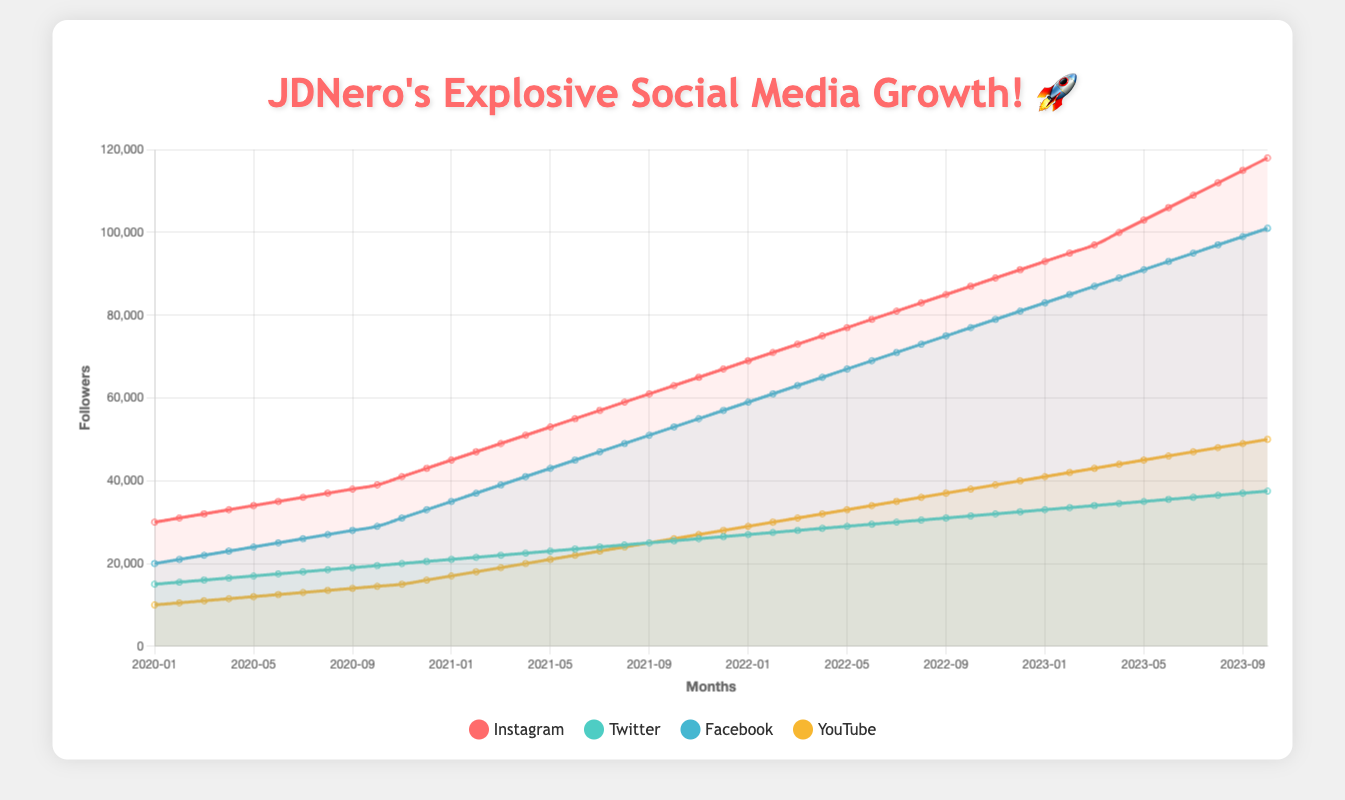What is the total number of followers JDNero had on Instagram by the end of 2022? At the end of 2022, the number of followers on Instagram is represented by the data point for December 2022. Referring to that data point in the "Instagram" series shows 91,000 followers.
Answer: 91,000 Which platform had the highest growth in followers from January 2020 to October 2023? To determine which platform had the highest growth, we need to subtract the number of followers in January 2020 from the number of followers in October 2023 for each platform. Instagram (118,000 - 30,000 = 88,000), Twitter (37,500 - 15,000 = 22,500), Facebook (101,000 - 20,000 = 81,000), YouTube (50,000 - 10,000 = 40,000). The highest growth occurred on Instagram with 88,000 new followers.
Answer: Instagram What is the average monthly follower growth for Twitter during 2021? To calculate the average monthly growth for Twitter in 2021, find the number of followers at the beginning of 2021 and at the end of 2021, then divide by the number of months. (24,500 - 21,000)/12. This calculates as (24,500 - 21,000) = 3,500; then dividing by 12 gives 3,500/12 ≈ 291.67 followers per month.
Answer: 291.67 Compare the total followers on Facebook and Twitter in December 2020. Which platform had more followers and by how much? In December 2020, Facebook had 57,000 followers and Twitter had 26,500 followers. By calculating the difference, 57,000 - 26,500 = 30,500, we can conclude that Facebook had more followers by 30,500.
Answer: Facebook, 30,500 What is the visual trend observed for YouTube followers over the entire period? Looking at the visual data for YouTube, there is a consistent upward trend with the number of followers increasing over the entire period. This indicates a steady growth in followers.
Answer: Upward trend What were the follower counts for Instagram, Twitter, Facebook, and YouTube in June 2021? For June 2021, refer to the specific data points for each platform. Instagram: 55,000; Twitter: 23,500; Facebook: 45,000; YouTube: 22,000.
Answer: Instagram: 55,000, Twitter: 23,500, Facebook: 45,000, YouTube: 22,000 During which year did JDNero’s Instagram followers experience the greatest incremental increase? To find the year with the greatest increase, calculate the yearly increments: 2020 (43,000 - 30,000 = 13,000), 2021 (67,000 - 43,000 = 24,000), 2022 (91,000 - 67,000 = 24,000). The greatest incremental increase occurred in 2021 and 2022 with 24,000 additional followers each year.
Answer: 2021 and 2022 